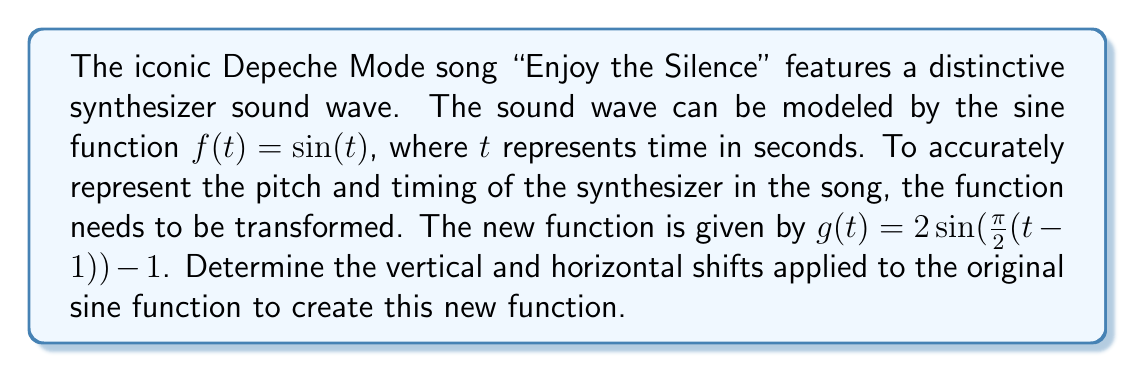Can you answer this question? To determine the vertical and horizontal shifts, we need to compare the given function $g(t) = 2\sin(\frac{\pi}{2}(t-1)) - 1$ to the general form of a transformed sine function:

$$f(t) = A\sin(B(t-C)) + D$$

Where:
- $A$ is the amplitude (not relevant for shifts)
- $B$ is the frequency (not relevant for shifts)
- $C$ is the horizontal shift
- $D$ is the vertical shift

Step 1: Identify the horizontal shift (C)
In our function, we have $(t-1)$ inside the sine function. This means $C = 1$.
The horizontal shift is 1 unit to the right.

Step 2: Identify the vertical shift (D)
In our function, we have $-1$ added at the end. This means $D = -1$.
The vertical shift is 1 unit down.

To visualize these shifts:
1. The original function $\sin(t)$ is shifted 1 unit to the right, resulting in $\sin(t-1)$.
2. Then, it's shifted 1 unit down, resulting in $\sin(t-1) - 1$.

The amplitude and frequency changes (represented by the 2 and $\frac{\pi}{2}$ respectively) do not affect the shifts.
Answer: The vertical shift is 1 unit down, and the horizontal shift is 1 unit to the right. 